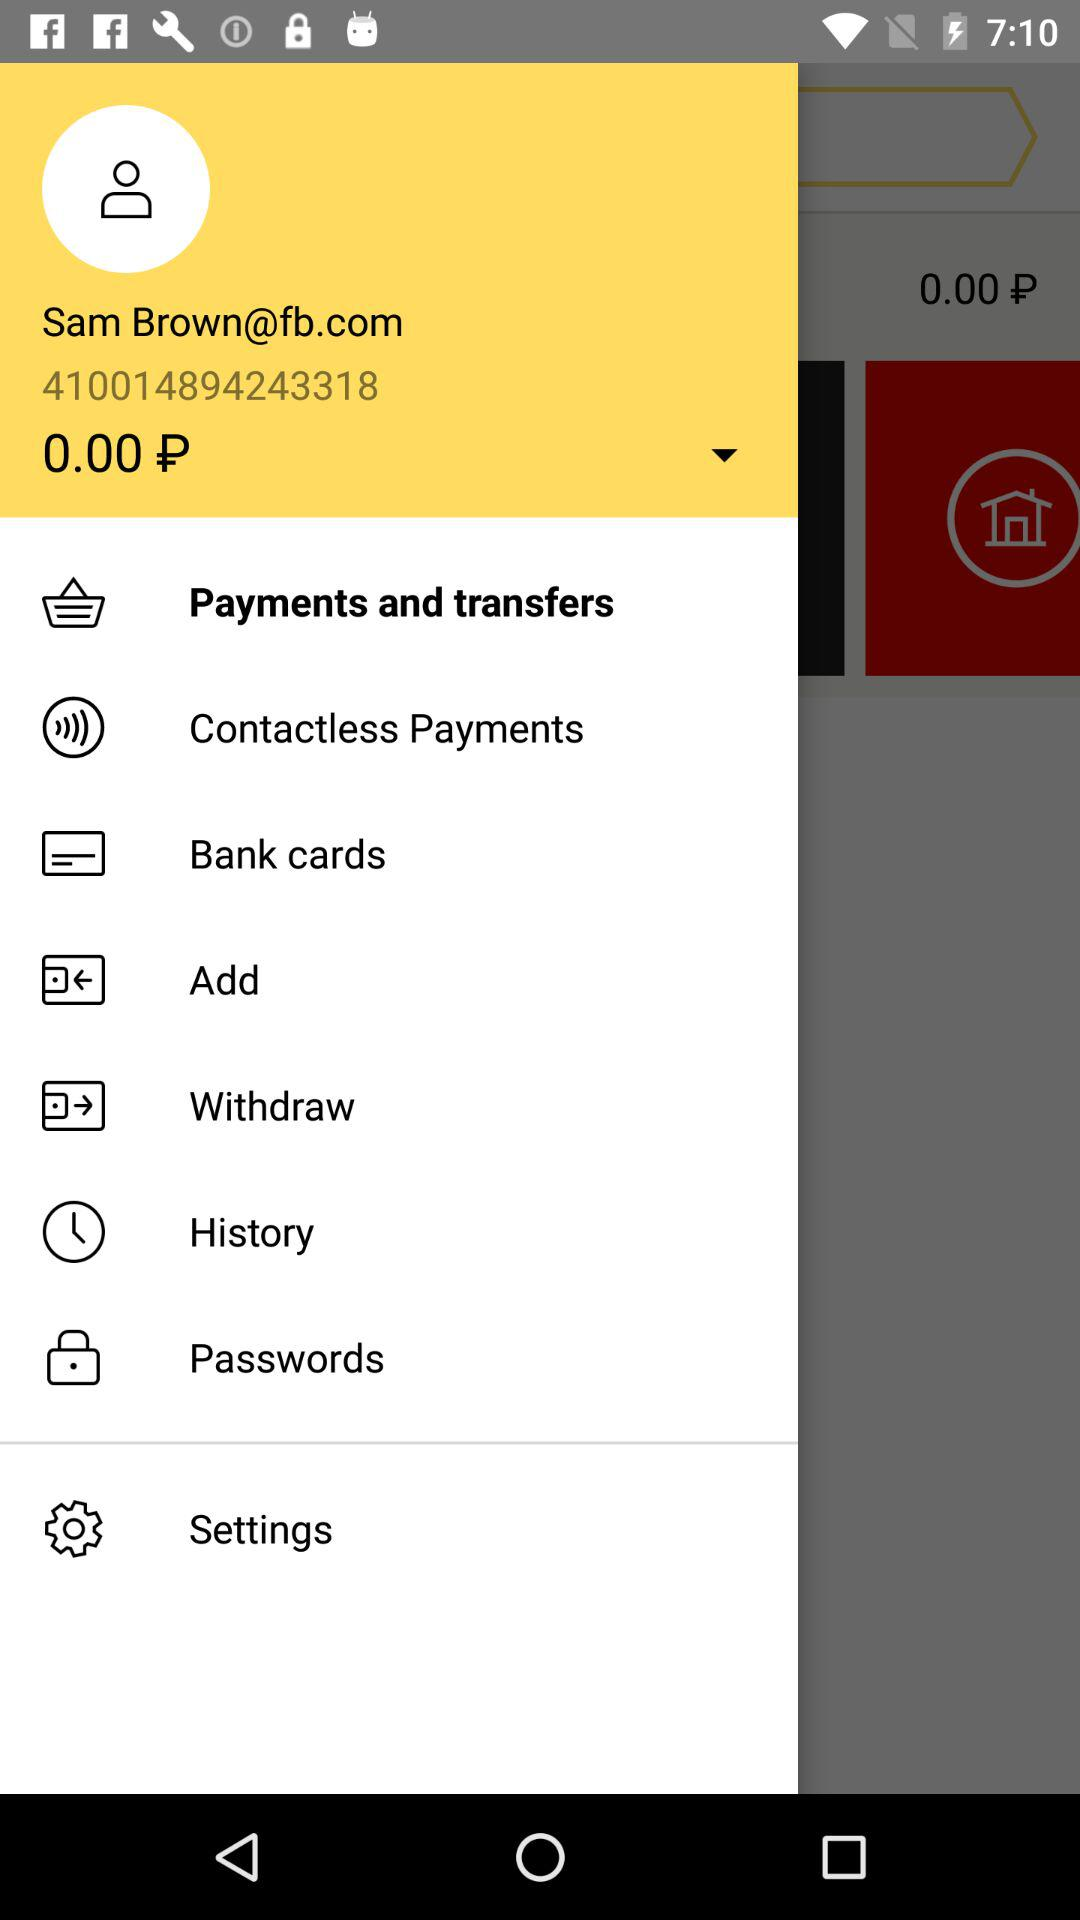How much money is in my account?
Answer the question using a single word or phrase. 0.00 P 